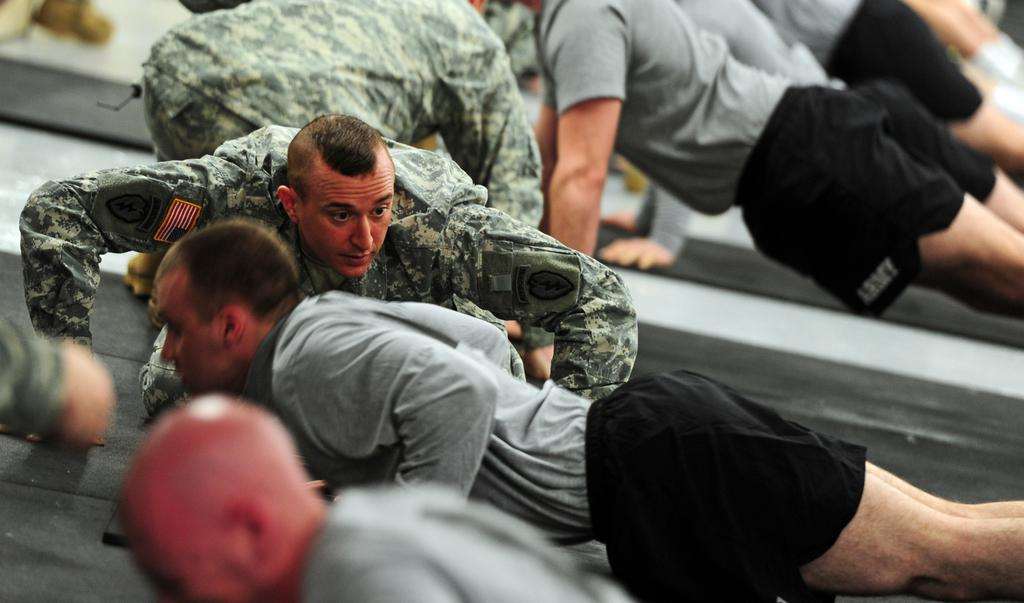How many people are in the image? There is a group of persons in the image. What is the position of the persons in the image? The persons are on the ground. Can you describe the attire of some of the persons in the image? Some of the persons are wearing military uniforms. What type of calculator can be seen in the hands of one of the persons in the image? There is no calculator present in the image. What kind of yam dish is being prepared by the group in the image? There is no yam dish or cooking activity depicted in the image. 